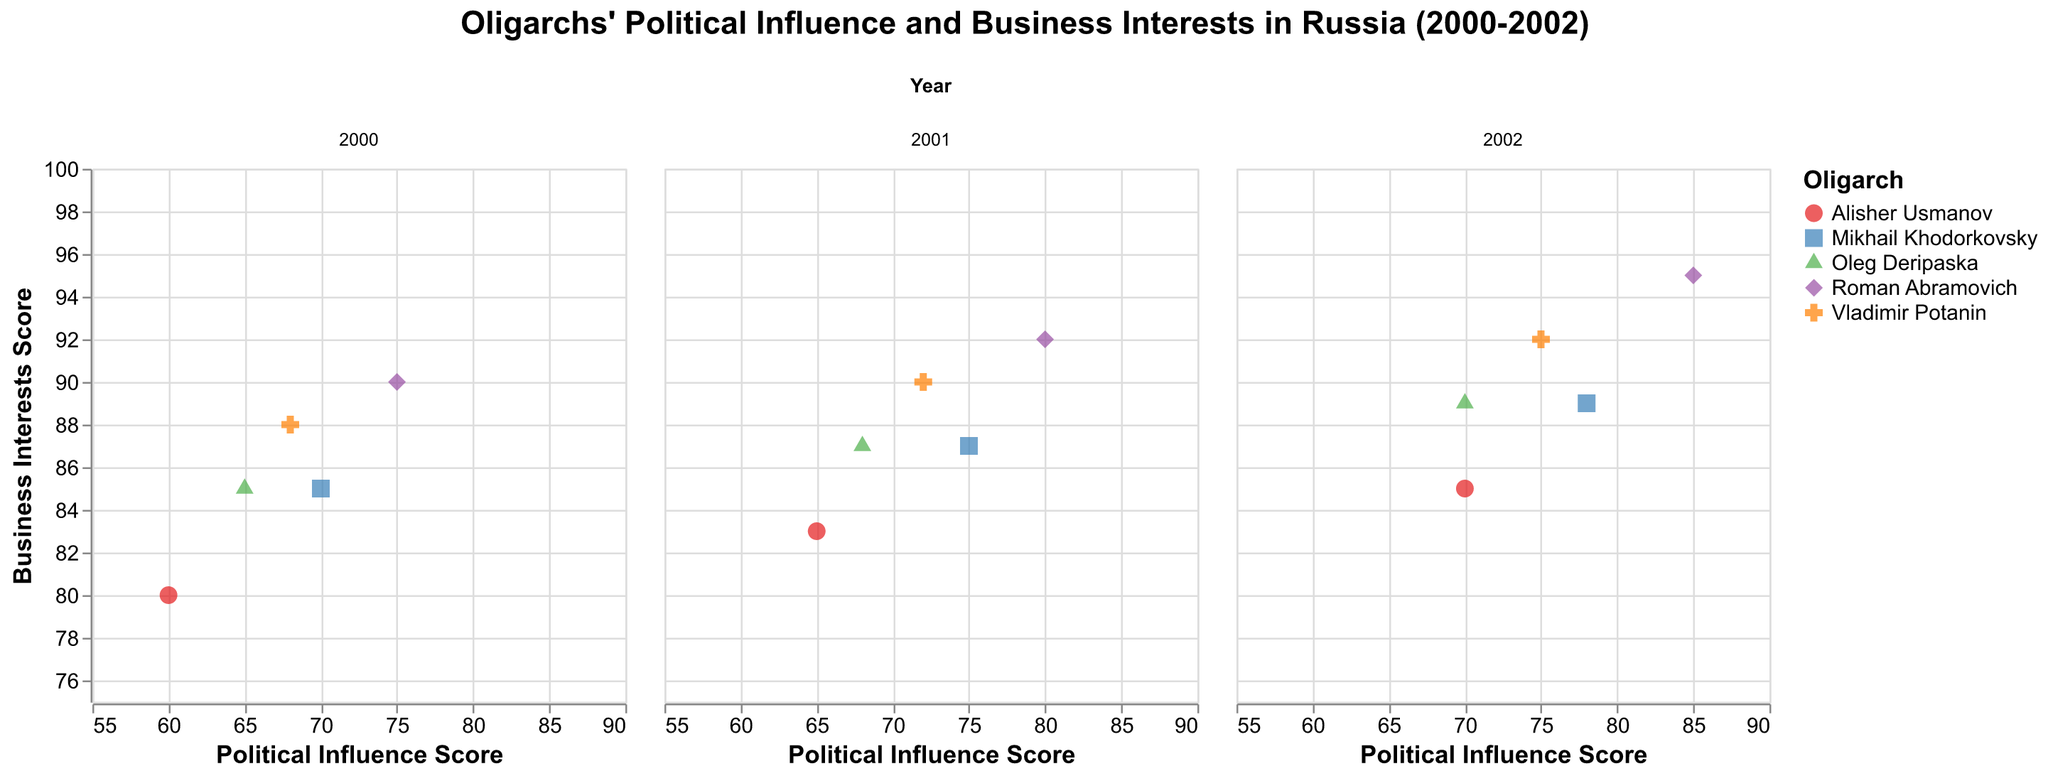What is the title of the figure? The title is typically positioned at the top of the figure. It summarizes the subject of the visualization
Answer: Oligarchs' Political Influence and Business Interests in Russia (2000-2002) How many oligarchs are represented in the figure? To determine this, identify the distinct names under the "Oligarch" field in the visualization's legend
Answer: Five oligarchs In which year did Roman Abramovich have the highest political influence score? Look at Roman Abramovich's scores in each subplot for different years and identify the highest value
Answer: 2002 Who had a higher business interests score in 2001, Mikhail Khodorkovsky or Alisher Usmanov? Compare the business interests scores of Mikhail Khodorkovsky and Alisher Usmanov in the subplot for 2001
Answer: Mikhail Khodorkovsky Which oligarch had the lowest political influence score in 2000? Check the political influence scores across all oligarchs in the subplot for the year 2000 and identify the lowest one
Answer: Alisher Usmanov Calculate the average business interests score for Vladimir Potanin over the three years. Sum up Vladimir Potanin’s business interests scores for 2000, 2001, and 2002, and then divide by 3. The values are 88, 90, and 92, respectively. (88 + 90 + 92) / 3 = 90
Answer: 90 Which oligarch shows the most consistent increase in both political influence and business interests scores over the period 2000 to 2002? By examining the trend for each oligarch across the different years, observe which one has a consistently increasing trend in both scores
Answer: Roman Abramovich Compare the business interests score change for Oleg Deripaska and Alisher Usmanov from 2000 to 2002. Who had a higher increase? Calculate the difference between the 2000 and 2002 scores for both oligarchs. Oleg Deripaska: (89 - 85), Alisher Usmanov: (85 - 80). Compare the increments
Answer: Oleg Deripaska Which year exhibits the highest overall business interests score among all oligarchs? Sum the business interests scores of all oligarchs for each year and compare the totals. For 2000: 90 + 85 + 80 + 88 + 85 = 428, for 2001: 92 + 87 + 83 + 90 + 87 = 439, for 2002: 95 + 89 + 85 + 92 + 89 = 450
Answer: 2002 Does any oligarch have a declining trend in political influence scores from 2000 to 2002? Review each oligarch's political influence scores for the years 2000, 2001, and 2002, and check for any declining patterns. All scores show an increasing trend, so no oligarch has a declining trend
Answer: No 